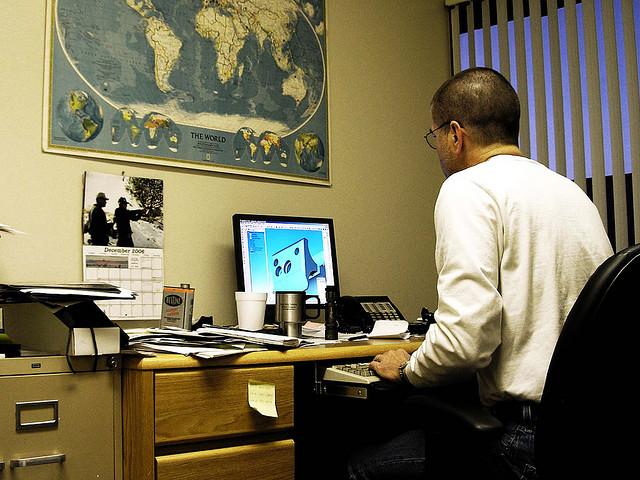What is the picture on the wall?
Write a very short answer. World map. What month is it?
Be succinct. December. What is on the front of the desk drawer?
Answer briefly. Post it note. 